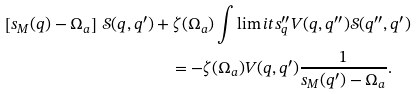<formula> <loc_0><loc_0><loc_500><loc_500>\left [ s _ { M } ( q ) - \Omega _ { a } \right ] \, { \mathcal { S } } ( q , q ^ { \prime } ) & + \zeta ( \Omega _ { a } ) \int \lim i t s _ { q } ^ { \prime \prime } V ( q , q ^ { \prime \prime } ) { \mathcal { S } } ( q ^ { \prime \prime } , q ^ { \prime } ) \\ & \quad = - \zeta ( \Omega _ { a } ) V ( q , q ^ { \prime } ) \frac { 1 } { s _ { M } ( q ^ { \prime } ) - \Omega _ { a } } .</formula> 